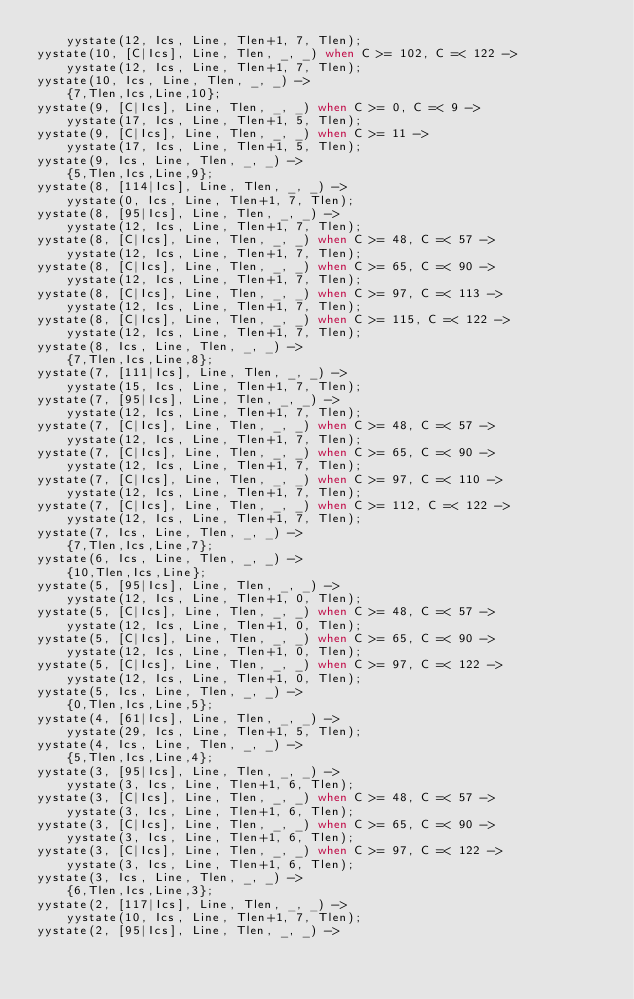Convert code to text. <code><loc_0><loc_0><loc_500><loc_500><_Erlang_>    yystate(12, Ics, Line, Tlen+1, 7, Tlen);
yystate(10, [C|Ics], Line, Tlen, _, _) when C >= 102, C =< 122 ->
    yystate(12, Ics, Line, Tlen+1, 7, Tlen);
yystate(10, Ics, Line, Tlen, _, _) ->
    {7,Tlen,Ics,Line,10};
yystate(9, [C|Ics], Line, Tlen, _, _) when C >= 0, C =< 9 ->
    yystate(17, Ics, Line, Tlen+1, 5, Tlen);
yystate(9, [C|Ics], Line, Tlen, _, _) when C >= 11 ->
    yystate(17, Ics, Line, Tlen+1, 5, Tlen);
yystate(9, Ics, Line, Tlen, _, _) ->
    {5,Tlen,Ics,Line,9};
yystate(8, [114|Ics], Line, Tlen, _, _) ->
    yystate(0, Ics, Line, Tlen+1, 7, Tlen);
yystate(8, [95|Ics], Line, Tlen, _, _) ->
    yystate(12, Ics, Line, Tlen+1, 7, Tlen);
yystate(8, [C|Ics], Line, Tlen, _, _) when C >= 48, C =< 57 ->
    yystate(12, Ics, Line, Tlen+1, 7, Tlen);
yystate(8, [C|Ics], Line, Tlen, _, _) when C >= 65, C =< 90 ->
    yystate(12, Ics, Line, Tlen+1, 7, Tlen);
yystate(8, [C|Ics], Line, Tlen, _, _) when C >= 97, C =< 113 ->
    yystate(12, Ics, Line, Tlen+1, 7, Tlen);
yystate(8, [C|Ics], Line, Tlen, _, _) when C >= 115, C =< 122 ->
    yystate(12, Ics, Line, Tlen+1, 7, Tlen);
yystate(8, Ics, Line, Tlen, _, _) ->
    {7,Tlen,Ics,Line,8};
yystate(7, [111|Ics], Line, Tlen, _, _) ->
    yystate(15, Ics, Line, Tlen+1, 7, Tlen);
yystate(7, [95|Ics], Line, Tlen, _, _) ->
    yystate(12, Ics, Line, Tlen+1, 7, Tlen);
yystate(7, [C|Ics], Line, Tlen, _, _) when C >= 48, C =< 57 ->
    yystate(12, Ics, Line, Tlen+1, 7, Tlen);
yystate(7, [C|Ics], Line, Tlen, _, _) when C >= 65, C =< 90 ->
    yystate(12, Ics, Line, Tlen+1, 7, Tlen);
yystate(7, [C|Ics], Line, Tlen, _, _) when C >= 97, C =< 110 ->
    yystate(12, Ics, Line, Tlen+1, 7, Tlen);
yystate(7, [C|Ics], Line, Tlen, _, _) when C >= 112, C =< 122 ->
    yystate(12, Ics, Line, Tlen+1, 7, Tlen);
yystate(7, Ics, Line, Tlen, _, _) ->
    {7,Tlen,Ics,Line,7};
yystate(6, Ics, Line, Tlen, _, _) ->
    {10,Tlen,Ics,Line};
yystate(5, [95|Ics], Line, Tlen, _, _) ->
    yystate(12, Ics, Line, Tlen+1, 0, Tlen);
yystate(5, [C|Ics], Line, Tlen, _, _) when C >= 48, C =< 57 ->
    yystate(12, Ics, Line, Tlen+1, 0, Tlen);
yystate(5, [C|Ics], Line, Tlen, _, _) when C >= 65, C =< 90 ->
    yystate(12, Ics, Line, Tlen+1, 0, Tlen);
yystate(5, [C|Ics], Line, Tlen, _, _) when C >= 97, C =< 122 ->
    yystate(12, Ics, Line, Tlen+1, 0, Tlen);
yystate(5, Ics, Line, Tlen, _, _) ->
    {0,Tlen,Ics,Line,5};
yystate(4, [61|Ics], Line, Tlen, _, _) ->
    yystate(29, Ics, Line, Tlen+1, 5, Tlen);
yystate(4, Ics, Line, Tlen, _, _) ->
    {5,Tlen,Ics,Line,4};
yystate(3, [95|Ics], Line, Tlen, _, _) ->
    yystate(3, Ics, Line, Tlen+1, 6, Tlen);
yystate(3, [C|Ics], Line, Tlen, _, _) when C >= 48, C =< 57 ->
    yystate(3, Ics, Line, Tlen+1, 6, Tlen);
yystate(3, [C|Ics], Line, Tlen, _, _) when C >= 65, C =< 90 ->
    yystate(3, Ics, Line, Tlen+1, 6, Tlen);
yystate(3, [C|Ics], Line, Tlen, _, _) when C >= 97, C =< 122 ->
    yystate(3, Ics, Line, Tlen+1, 6, Tlen);
yystate(3, Ics, Line, Tlen, _, _) ->
    {6,Tlen,Ics,Line,3};
yystate(2, [117|Ics], Line, Tlen, _, _) ->
    yystate(10, Ics, Line, Tlen+1, 7, Tlen);
yystate(2, [95|Ics], Line, Tlen, _, _) -></code> 